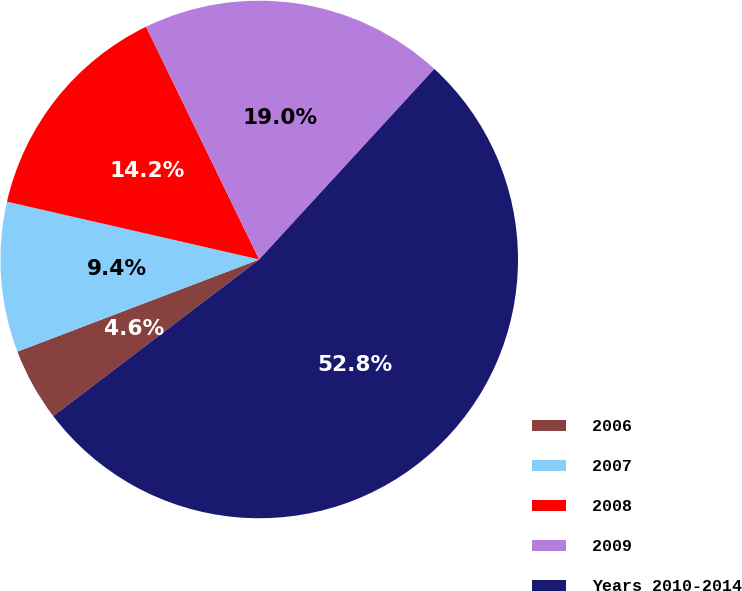Convert chart to OTSL. <chart><loc_0><loc_0><loc_500><loc_500><pie_chart><fcel>2006<fcel>2007<fcel>2008<fcel>2009<fcel>Years 2010-2014<nl><fcel>4.55%<fcel>9.38%<fcel>14.21%<fcel>19.03%<fcel>52.82%<nl></chart> 